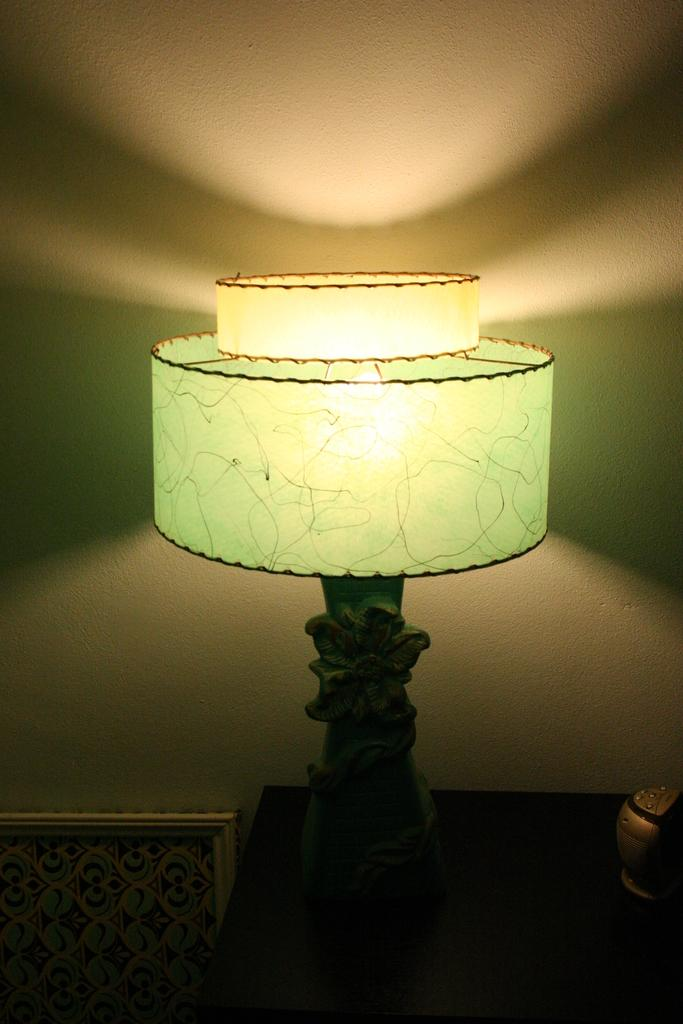What object can be seen in the image that provides light? There is a lamp in the image that provides light. What can be found on the table in the image? There is a device on the table in the image. What is located on the left side of the image? There is a frame on the left side of the image. What part of the room is visible in the image? The wall is visible at the top of the image. How does the girl interact with the coach in the image? There is no girl or coach present in the image. 